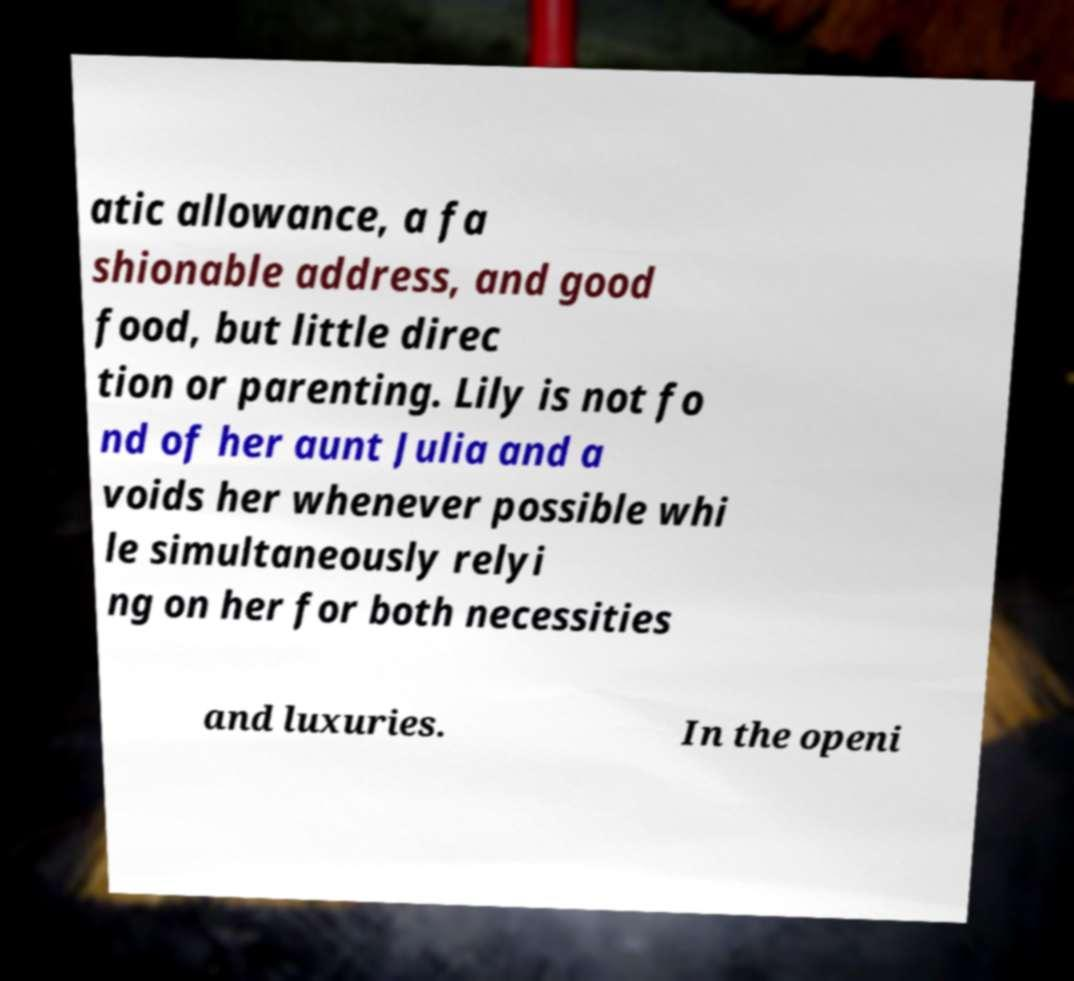Please read and relay the text visible in this image. What does it say? atic allowance, a fa shionable address, and good food, but little direc tion or parenting. Lily is not fo nd of her aunt Julia and a voids her whenever possible whi le simultaneously relyi ng on her for both necessities and luxuries. In the openi 